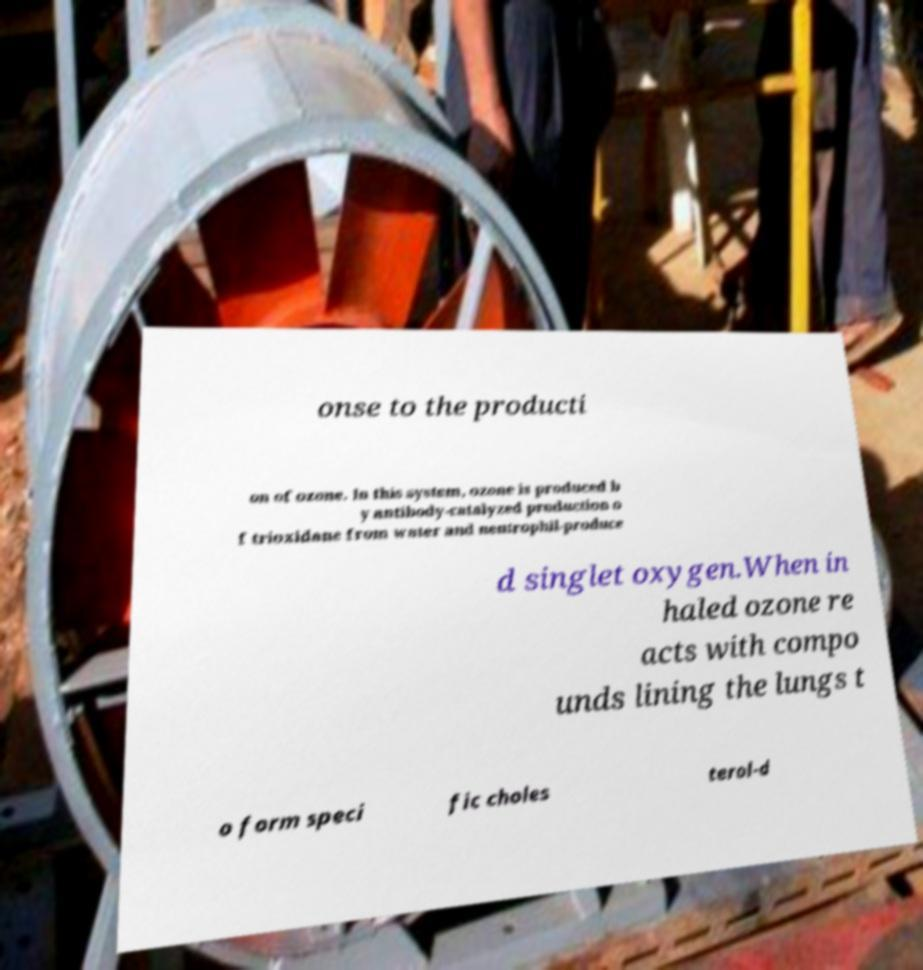Please identify and transcribe the text found in this image. onse to the producti on of ozone. In this system, ozone is produced b y antibody-catalyzed production o f trioxidane from water and neutrophil-produce d singlet oxygen.When in haled ozone re acts with compo unds lining the lungs t o form speci fic choles terol-d 